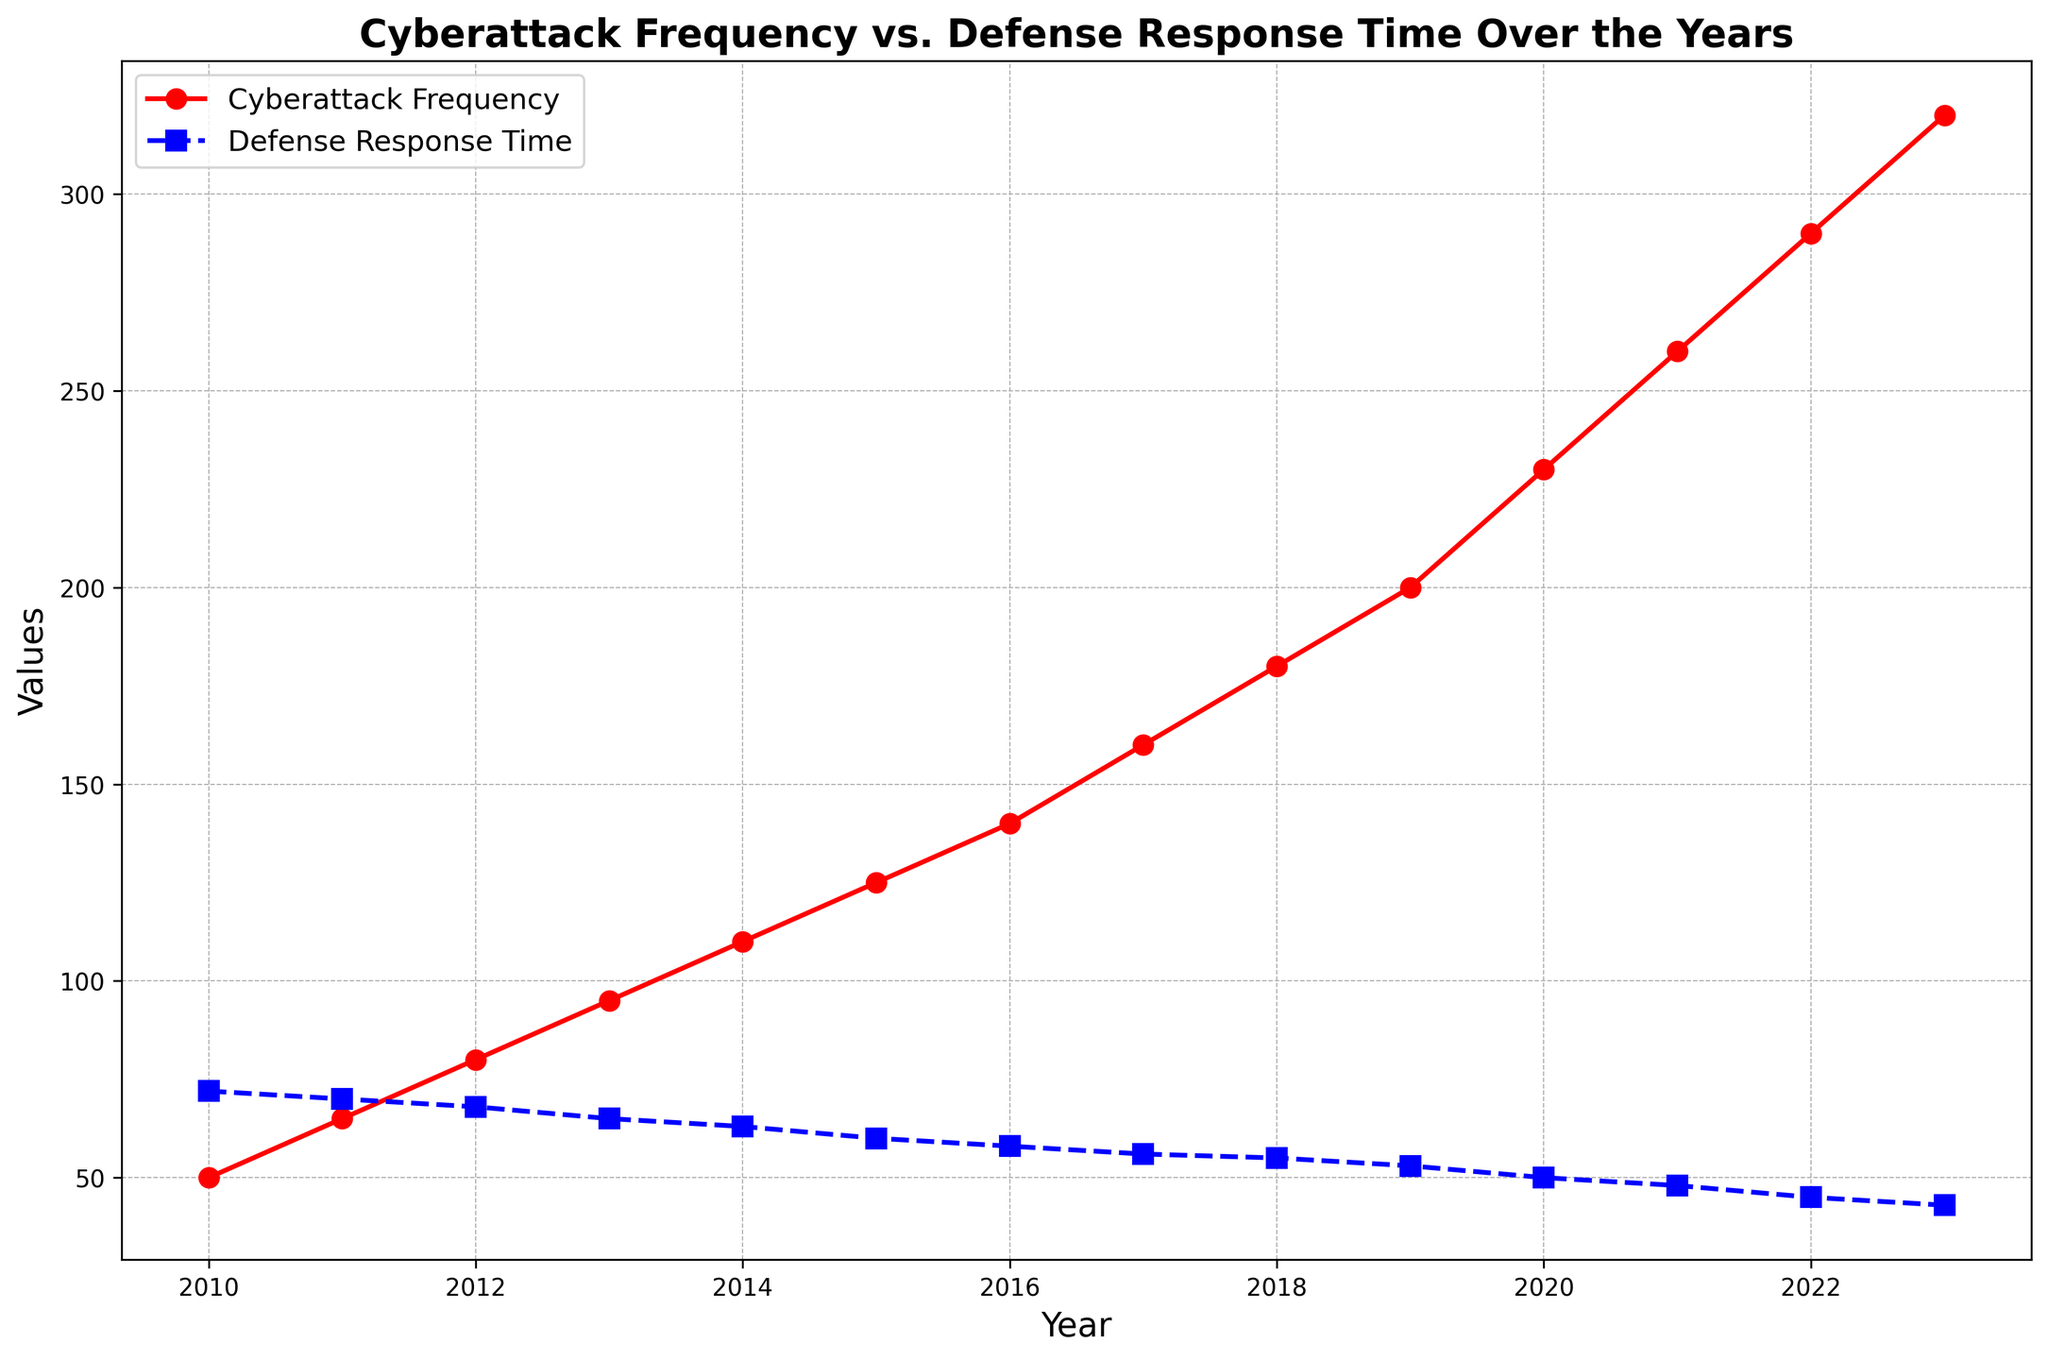What's the trend of Cyberattack Frequency from 2010 to 2023? Look at the red line for Cyberattack Frequency. It consistently rises from 50 in 2010 to 320 in 2023, showing an upward trend throughout the years.
Answer: Upward trend In which year did the Defense Response Time experience the biggest drop compared to the previous year? To identify the biggest drop, compare the difference in Defense Response Time between consecutive years. Between 2010 and 2023, the biggest drop occurred from 2019 (53) to 2020 (50) with a decrease of 3 units.
Answer: 2020 What is the average Cyberattack Frequency over the years 2010 to 2015? Add the Cyberattack Frequency values from 2010 to 2015 (50 + 65 + 80 + 95 + 110 + 125 = 525) and divide by 6 (number of years). The average is 525 / 6 = 87.5.
Answer: 87.5 Compare the Cyberattack Frequency in 2013 and 2018. Which year had a higher frequency, and by how much? Cyberattack Frequency in 2013 is 95, and in 2018 it is 180. Subtract 95 from 180 to find the difference. 180 - 95 = 85. 2018 had a higher frequency by 85.
Answer: 2018, by 85 What is the percentage decrease in Defense Response Time from 2010 to 2023? The Defense Response Time in 2010 is 72, and in 2023 it is 43. First, find the absolute decrease: 72 - 43 = 29. Next, calculate the percentage decrease: (29 / 72) * 100 ≈ 40.28%.
Answer: 40.28% Which color represents the Defense Response Time in the plot, and what is its trend over the years? The Defense Response Time is represented by the blue line. It shows a decreasing trend from 72 in 2010 to 43 in 2023.
Answer: Blue, decreasing What's the difference in Cyberattack Frequency between the first and last year of the data? The Cyberattack Frequency in 2010 is 50, and in 2023 it is 320. Subtract 50 from 320 to find the difference. 320 - 50 = 270.
Answer: 270 Which year saw the Defense Response Time drop below 60 for the first time, and what was the exact time? Looking at the blue line, the Defense Response Time first dropped below 60 in 2015. The exact time was 58 in 2016.
Answer: 2016, 58 Is there a year where Cyberattack Frequency and Defense Response Time remained constant compared to the previous year? Examine the changes between consecutive years for both Cyberattack Frequency and Defense Response Time. There are no years where both metrics remained constant; they either increased or decreased every year.
Answer: No 